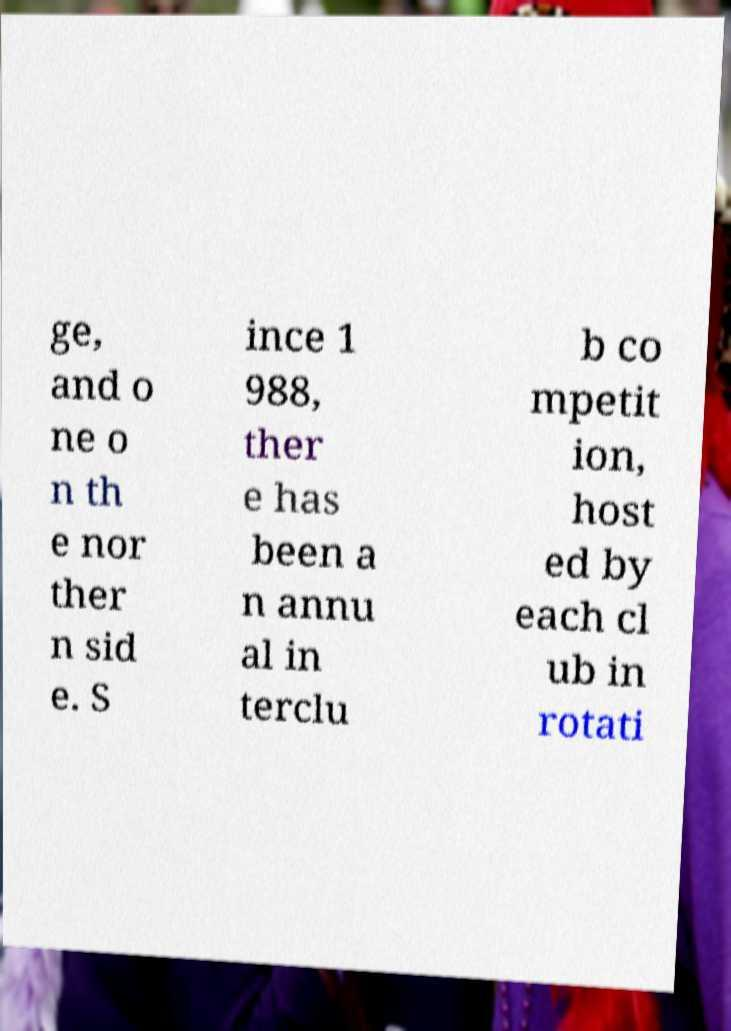What messages or text are displayed in this image? I need them in a readable, typed format. ge, and o ne o n th e nor ther n sid e. S ince 1 988, ther e has been a n annu al in terclu b co mpetit ion, host ed by each cl ub in rotati 